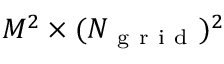<formula> <loc_0><loc_0><loc_500><loc_500>M ^ { 2 } \times ( N _ { g r i d } ) ^ { 2 }</formula> 